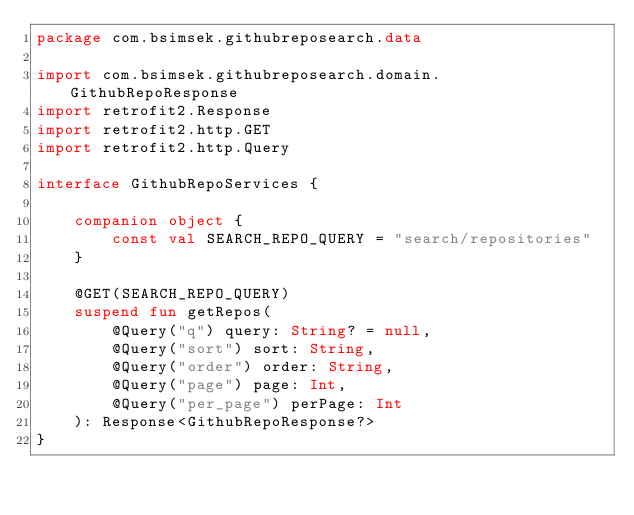<code> <loc_0><loc_0><loc_500><loc_500><_Kotlin_>package com.bsimsek.githubreposearch.data

import com.bsimsek.githubreposearch.domain.GithubRepoResponse
import retrofit2.Response
import retrofit2.http.GET
import retrofit2.http.Query

interface GithubRepoServices {

    companion object {
        const val SEARCH_REPO_QUERY = "search/repositories"
    }

    @GET(SEARCH_REPO_QUERY)
    suspend fun getRepos(
        @Query("q") query: String? = null,
        @Query("sort") sort: String,
        @Query("order") order: String,
        @Query("page") page: Int,
        @Query("per_page") perPage: Int
    ): Response<GithubRepoResponse?>
}</code> 